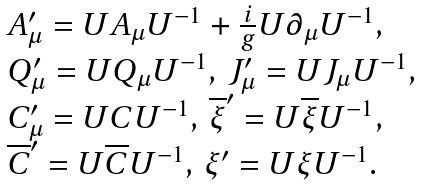<formula> <loc_0><loc_0><loc_500><loc_500>\begin{array} { l } { { A _ { \mu } ^ { \prime } = U A _ { \mu } U ^ { - 1 } + \frac { i } { g } U \partial _ { \mu } U ^ { - 1 } , } } \\ { { Q _ { \mu } ^ { \prime } = U Q _ { \mu } U ^ { - 1 } , \, J _ { \mu } ^ { \prime } = U J _ { \mu } U ^ { - 1 } , } } \\ { { C _ { \mu } ^ { \prime } = U C U ^ { - 1 } , \, \overline { \xi } ^ { \prime } = U \overline { \xi } U ^ { - 1 } , } } \\ { { \overline { C } ^ { \prime } = U \overline { C } U ^ { - 1 } , \, \xi ^ { \prime } = U \xi U ^ { - 1 } . } } \end{array}</formula> 